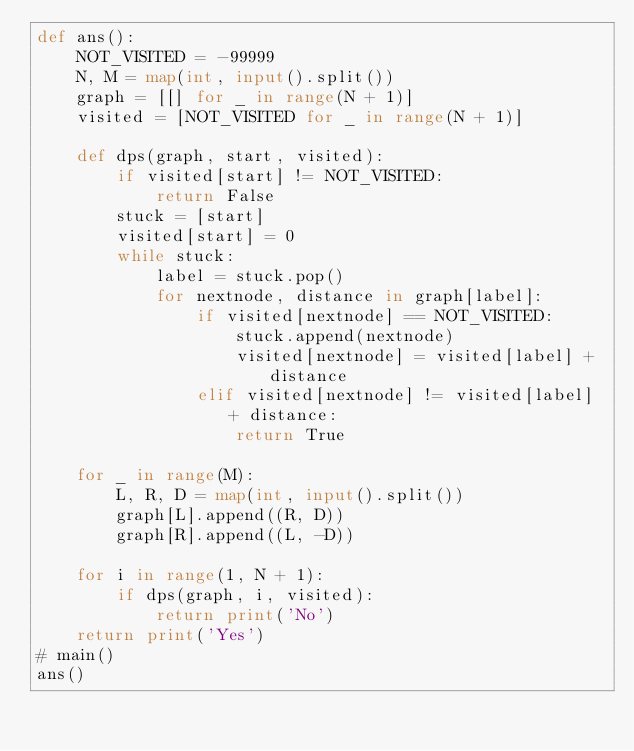Convert code to text. <code><loc_0><loc_0><loc_500><loc_500><_Python_>def ans():
    NOT_VISITED = -99999
    N, M = map(int, input().split())
    graph = [[] for _ in range(N + 1)]
    visited = [NOT_VISITED for _ in range(N + 1)]

    def dps(graph, start, visited):
        if visited[start] != NOT_VISITED:
            return False
        stuck = [start]
        visited[start] = 0
        while stuck:
            label = stuck.pop()
            for nextnode, distance in graph[label]:
                if visited[nextnode] == NOT_VISITED:
                    stuck.append(nextnode)
                    visited[nextnode] = visited[label] + distance
                elif visited[nextnode] != visited[label] + distance:
                    return True

    for _ in range(M):
        L, R, D = map(int, input().split())
        graph[L].append((R, D))
        graph[R].append((L, -D))

    for i in range(1, N + 1):
        if dps(graph, i, visited):
            return print('No')
    return print('Yes')
# main()
ans()</code> 